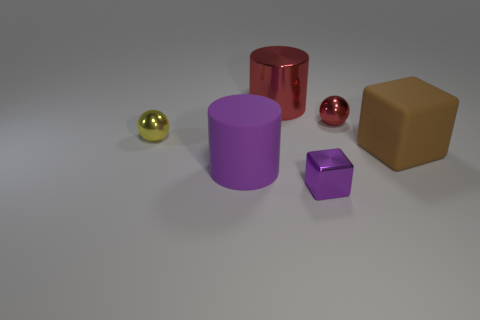Subtract all balls. How many objects are left? 4 Add 3 big purple blocks. How many objects exist? 9 Subtract 0 cyan cylinders. How many objects are left? 6 Subtract 2 cylinders. How many cylinders are left? 0 Subtract all yellow balls. Subtract all gray blocks. How many balls are left? 1 Subtract all blue blocks. How many red balls are left? 1 Subtract all tiny yellow matte objects. Subtract all purple matte cylinders. How many objects are left? 5 Add 5 shiny cylinders. How many shiny cylinders are left? 6 Add 5 large red things. How many large red things exist? 6 